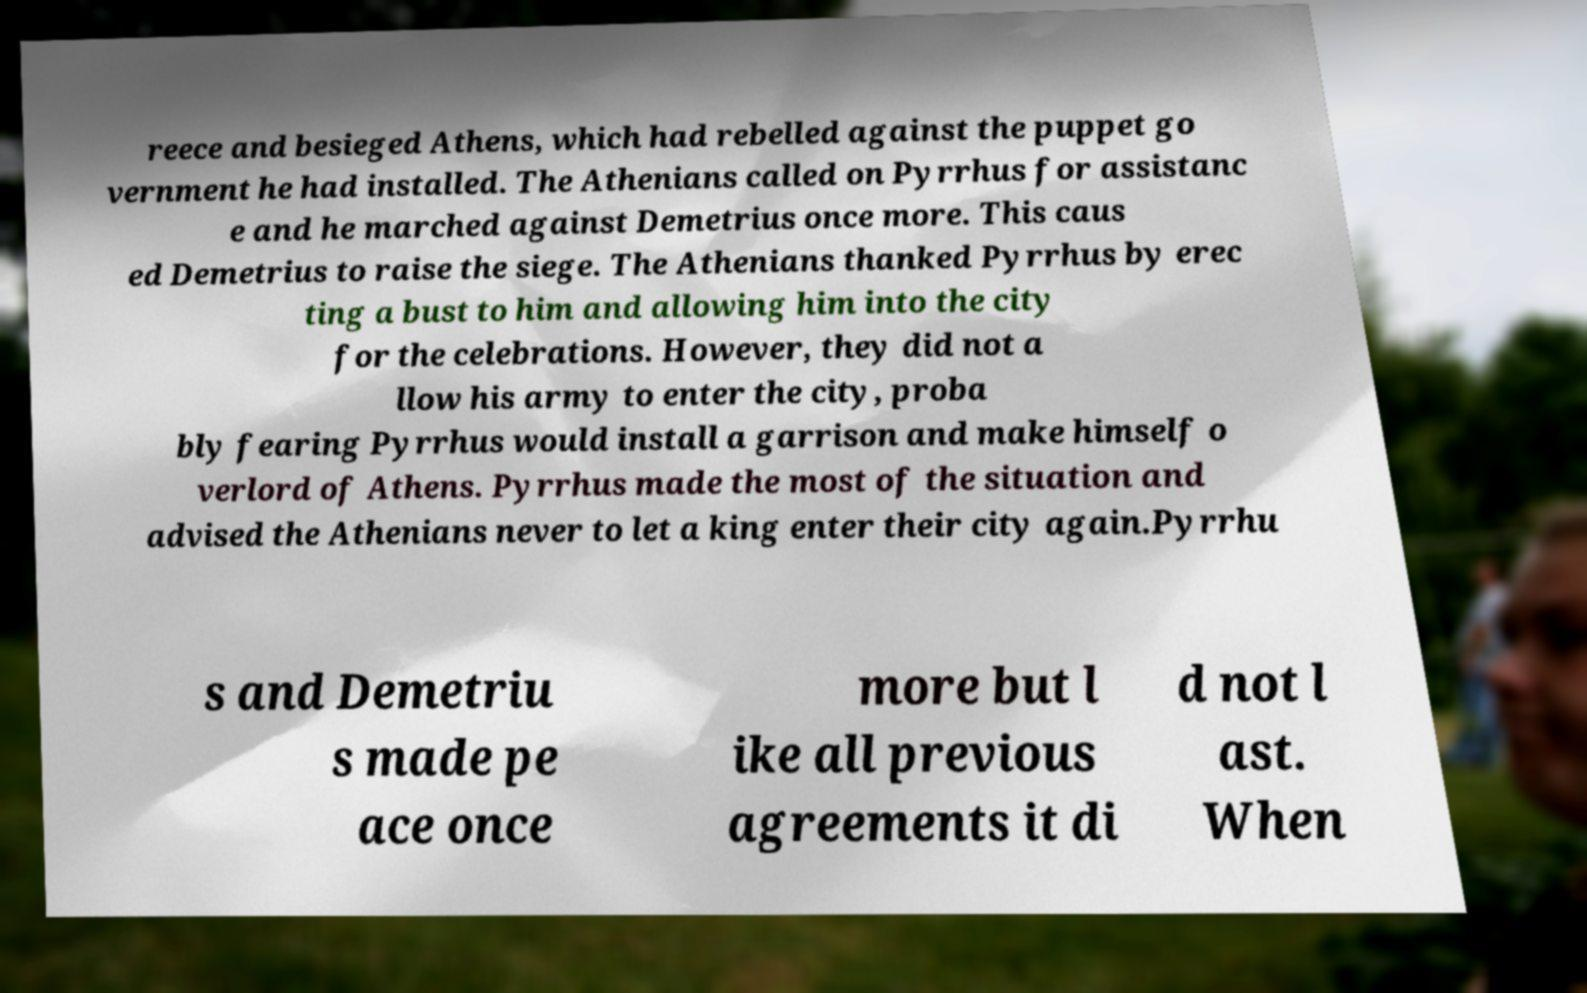For documentation purposes, I need the text within this image transcribed. Could you provide that? reece and besieged Athens, which had rebelled against the puppet go vernment he had installed. The Athenians called on Pyrrhus for assistanc e and he marched against Demetrius once more. This caus ed Demetrius to raise the siege. The Athenians thanked Pyrrhus by erec ting a bust to him and allowing him into the city for the celebrations. However, they did not a llow his army to enter the city, proba bly fearing Pyrrhus would install a garrison and make himself o verlord of Athens. Pyrrhus made the most of the situation and advised the Athenians never to let a king enter their city again.Pyrrhu s and Demetriu s made pe ace once more but l ike all previous agreements it di d not l ast. When 